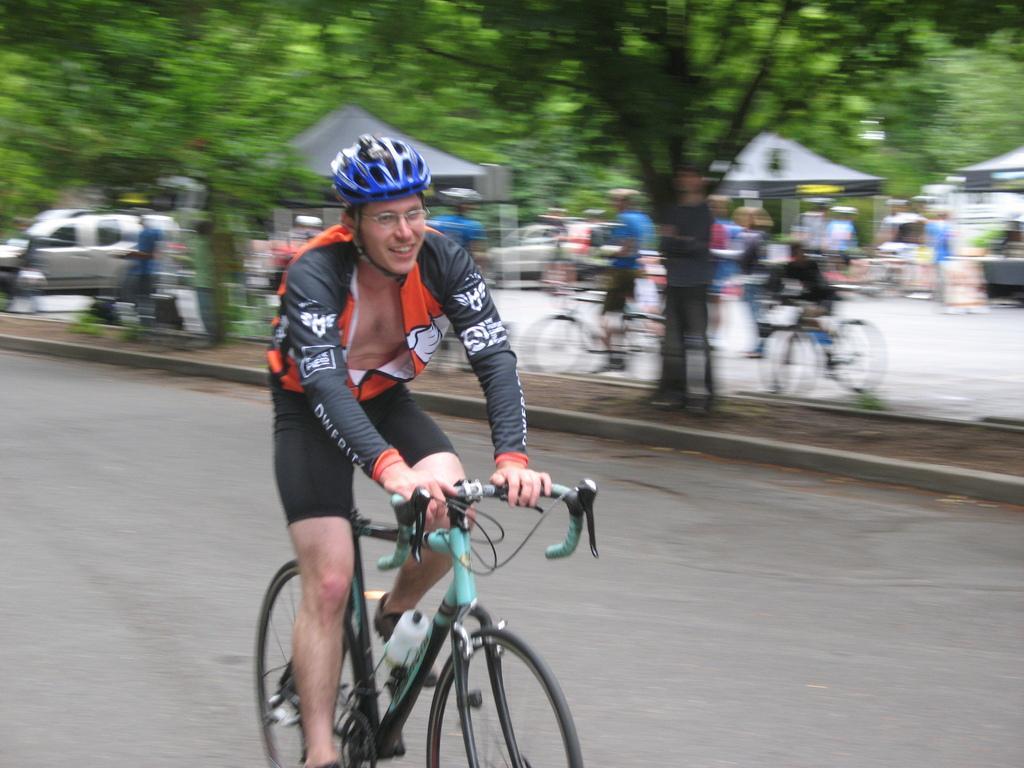Describe this image in one or two sentences. In this image I can see a person wearing black, orange and white colored dress and blue color helmet is riding a bicycle which is black and green in color on the road. In the background I can see few trees, few other persons, few vehicles and few tents. 